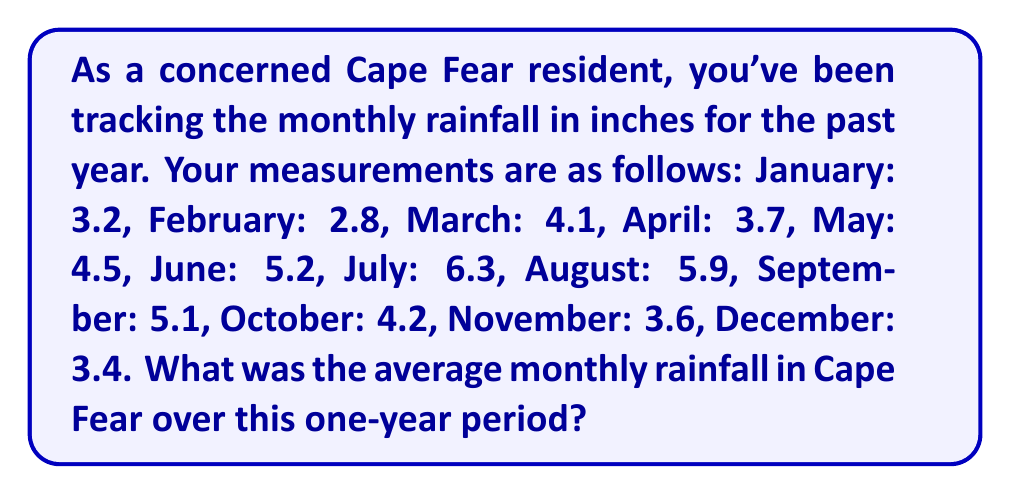Teach me how to tackle this problem. To find the average monthly rainfall, we need to:

1. Sum up all the monthly rainfall measurements
2. Divide the sum by the number of months (12)

Let's calculate step by step:

1. Sum of rainfall measurements:
   $$3.2 + 2.8 + 4.1 + 3.7 + 4.5 + 5.2 + 6.3 + 5.9 + 5.1 + 4.2 + 3.6 + 3.4 = 52$$

2. Divide by the number of months:
   $$\text{Average} = \frac{\text{Sum of measurements}}{\text{Number of months}} = \frac{52}{12} = 4.33333...$$

3. Round to two decimal places:
   $$4.33333... \approx 4.33$$

Therefore, the average monthly rainfall in Cape Fear over this one-year period was approximately 4.33 inches.
Answer: $4.33$ inches 